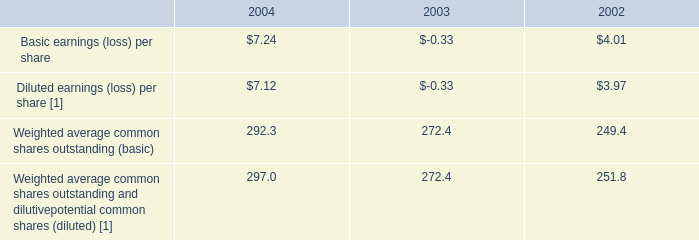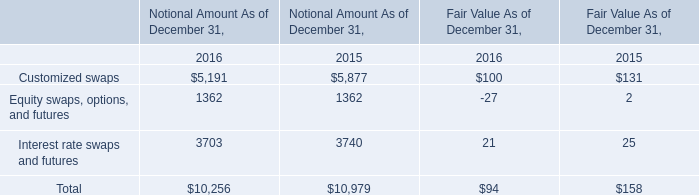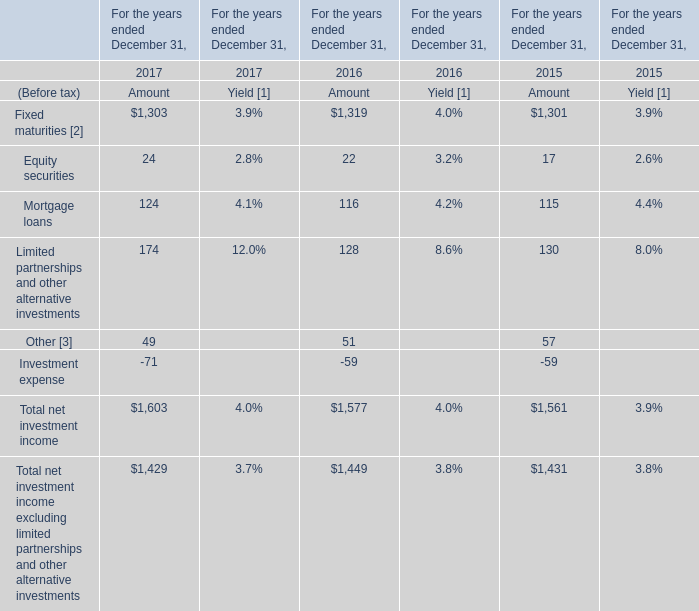What's the average of the Mortgage loans for Amount in the years where Equity swaps, options, and futures for Notional Amount As of December 31, is positive? 
Computations: ((116 + 115) / 2)
Answer: 115.5. 